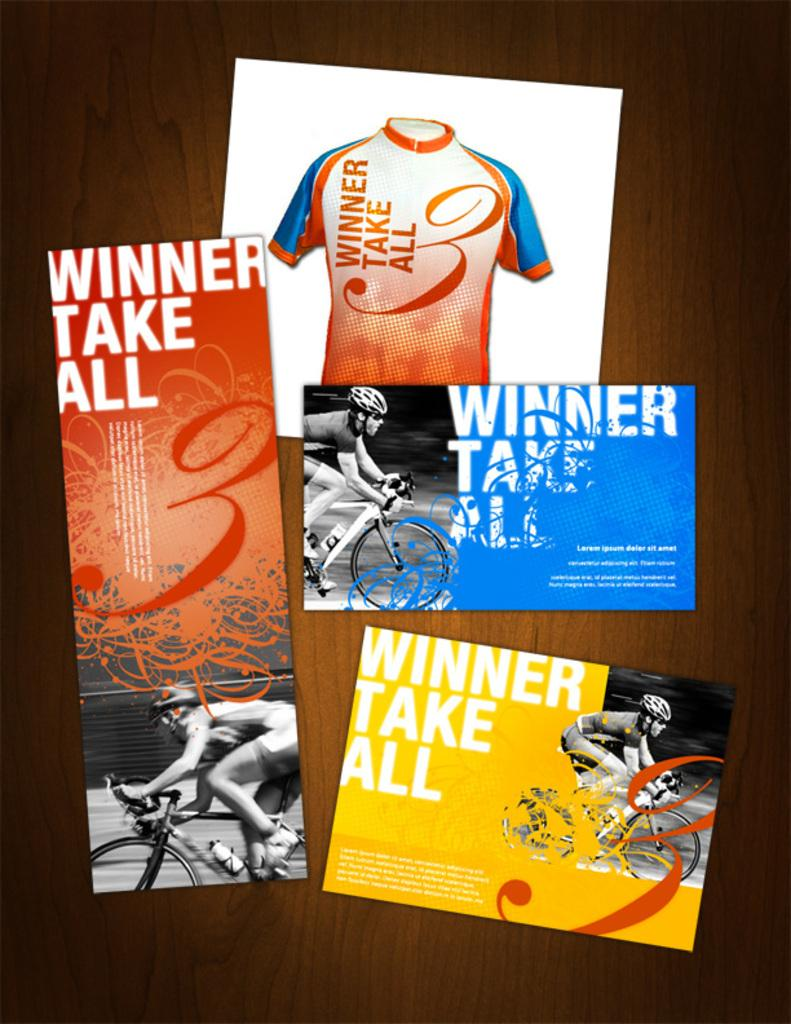What is the main subject of the flyer in the image? The main subject of the flyer is a person riding a bicycle. What type of clothing is depicted on the flyer? There is a t-shirt depicted in the image. Is there any text present on the flyer? Yes, there is text present on the flyer. How many pigs are shown playing with the t-shirt in the image? There are no pigs present in the image, and therefore no such activity can be observed. 